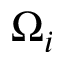<formula> <loc_0><loc_0><loc_500><loc_500>\Omega _ { i }</formula> 